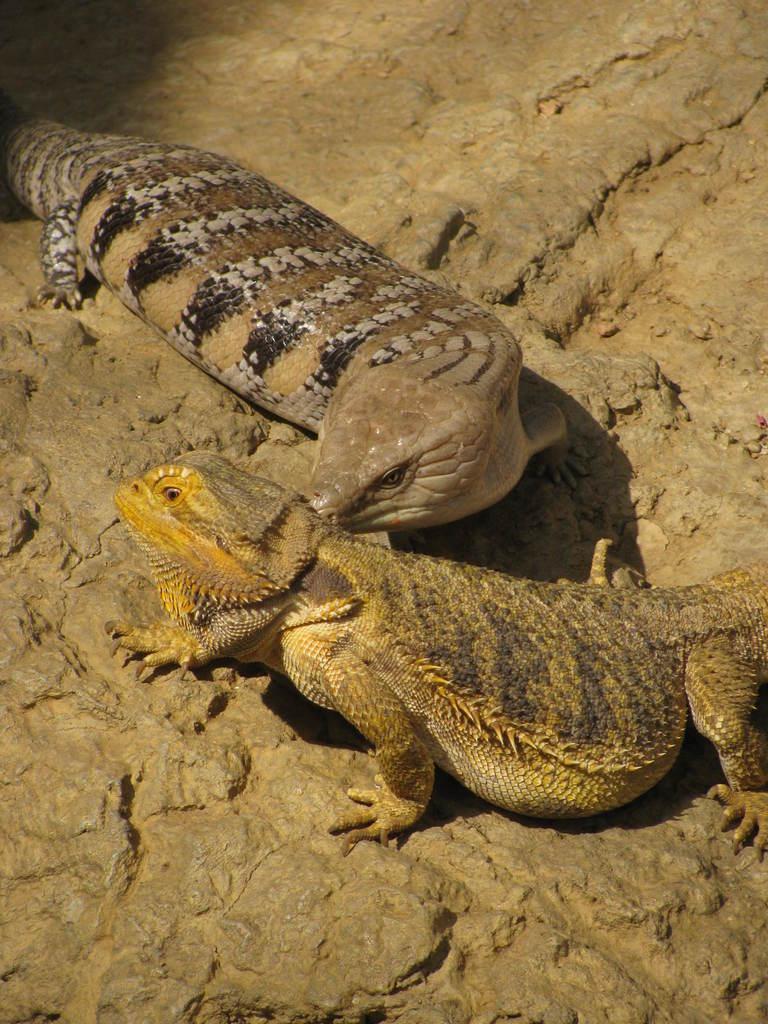How would you summarize this image in a sentence or two? In this image I can see two reptiles on the brown color surface and the reptiles are in cream, brown and black color. 